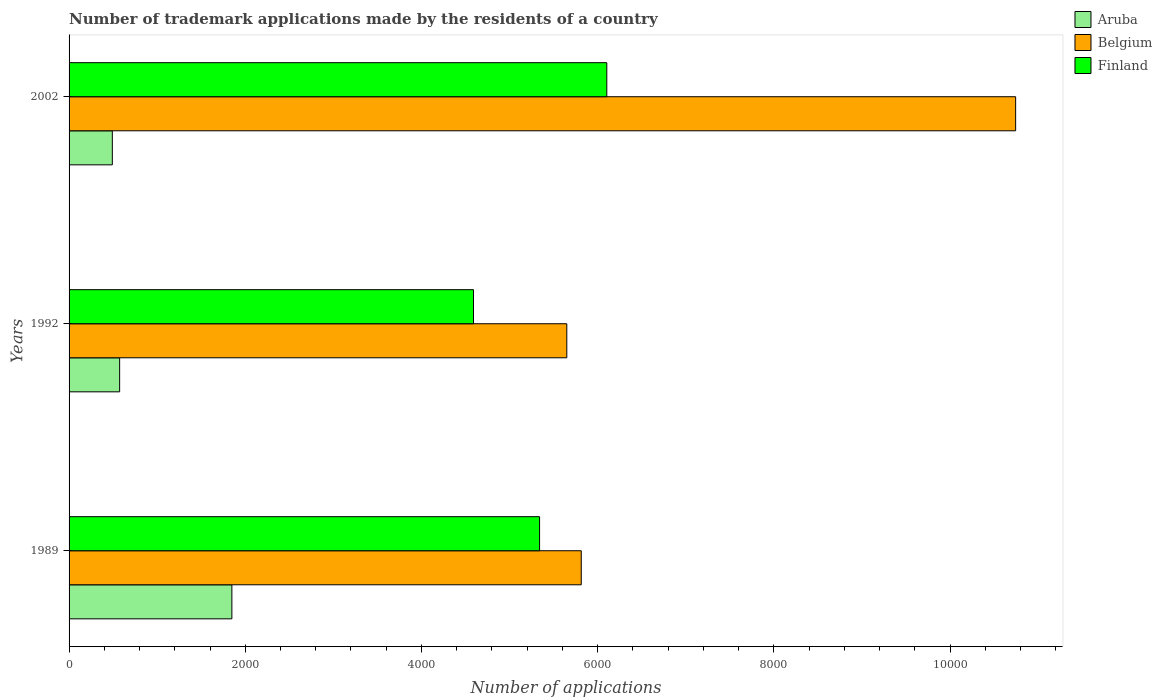How many groups of bars are there?
Ensure brevity in your answer.  3. Are the number of bars per tick equal to the number of legend labels?
Your answer should be very brief. Yes. Are the number of bars on each tick of the Y-axis equal?
Provide a succinct answer. Yes. How many bars are there on the 2nd tick from the bottom?
Make the answer very short. 3. What is the number of trademark applications made by the residents in Aruba in 2002?
Provide a short and direct response. 491. Across all years, what is the maximum number of trademark applications made by the residents in Aruba?
Make the answer very short. 1848. Across all years, what is the minimum number of trademark applications made by the residents in Belgium?
Your response must be concise. 5650. What is the total number of trademark applications made by the residents in Finland in the graph?
Give a very brief answer. 1.60e+04. What is the difference between the number of trademark applications made by the residents in Aruba in 1989 and that in 1992?
Your answer should be very brief. 1274. What is the difference between the number of trademark applications made by the residents in Belgium in 1989 and the number of trademark applications made by the residents in Aruba in 2002?
Offer a very short reply. 5323. What is the average number of trademark applications made by the residents in Belgium per year?
Keep it short and to the point. 7403. In the year 1992, what is the difference between the number of trademark applications made by the residents in Aruba and number of trademark applications made by the residents in Belgium?
Your answer should be very brief. -5076. What is the ratio of the number of trademark applications made by the residents in Belgium in 1989 to that in 2002?
Ensure brevity in your answer.  0.54. Is the number of trademark applications made by the residents in Belgium in 1989 less than that in 1992?
Make the answer very short. No. What is the difference between the highest and the second highest number of trademark applications made by the residents in Belgium?
Your answer should be compact. 4931. What is the difference between the highest and the lowest number of trademark applications made by the residents in Belgium?
Provide a succinct answer. 5095. Is the sum of the number of trademark applications made by the residents in Belgium in 1992 and 2002 greater than the maximum number of trademark applications made by the residents in Aruba across all years?
Provide a short and direct response. Yes. What does the 1st bar from the top in 2002 represents?
Provide a succinct answer. Finland. What does the 1st bar from the bottom in 1992 represents?
Offer a terse response. Aruba. Is it the case that in every year, the sum of the number of trademark applications made by the residents in Finland and number of trademark applications made by the residents in Aruba is greater than the number of trademark applications made by the residents in Belgium?
Offer a terse response. No. How many bars are there?
Your answer should be very brief. 9. How many years are there in the graph?
Ensure brevity in your answer.  3. Are the values on the major ticks of X-axis written in scientific E-notation?
Offer a terse response. No. Does the graph contain grids?
Provide a succinct answer. No. How many legend labels are there?
Give a very brief answer. 3. What is the title of the graph?
Your answer should be compact. Number of trademark applications made by the residents of a country. What is the label or title of the X-axis?
Keep it short and to the point. Number of applications. What is the label or title of the Y-axis?
Offer a very short reply. Years. What is the Number of applications in Aruba in 1989?
Your response must be concise. 1848. What is the Number of applications in Belgium in 1989?
Keep it short and to the point. 5814. What is the Number of applications of Finland in 1989?
Your answer should be very brief. 5341. What is the Number of applications in Aruba in 1992?
Give a very brief answer. 574. What is the Number of applications in Belgium in 1992?
Your answer should be compact. 5650. What is the Number of applications in Finland in 1992?
Make the answer very short. 4591. What is the Number of applications in Aruba in 2002?
Offer a very short reply. 491. What is the Number of applications of Belgium in 2002?
Offer a very short reply. 1.07e+04. What is the Number of applications of Finland in 2002?
Offer a very short reply. 6104. Across all years, what is the maximum Number of applications of Aruba?
Offer a terse response. 1848. Across all years, what is the maximum Number of applications in Belgium?
Make the answer very short. 1.07e+04. Across all years, what is the maximum Number of applications of Finland?
Keep it short and to the point. 6104. Across all years, what is the minimum Number of applications of Aruba?
Keep it short and to the point. 491. Across all years, what is the minimum Number of applications in Belgium?
Provide a short and direct response. 5650. Across all years, what is the minimum Number of applications of Finland?
Your answer should be very brief. 4591. What is the total Number of applications in Aruba in the graph?
Offer a terse response. 2913. What is the total Number of applications in Belgium in the graph?
Keep it short and to the point. 2.22e+04. What is the total Number of applications of Finland in the graph?
Your response must be concise. 1.60e+04. What is the difference between the Number of applications of Aruba in 1989 and that in 1992?
Make the answer very short. 1274. What is the difference between the Number of applications in Belgium in 1989 and that in 1992?
Give a very brief answer. 164. What is the difference between the Number of applications of Finland in 1989 and that in 1992?
Ensure brevity in your answer.  750. What is the difference between the Number of applications of Aruba in 1989 and that in 2002?
Offer a very short reply. 1357. What is the difference between the Number of applications of Belgium in 1989 and that in 2002?
Give a very brief answer. -4931. What is the difference between the Number of applications of Finland in 1989 and that in 2002?
Give a very brief answer. -763. What is the difference between the Number of applications of Aruba in 1992 and that in 2002?
Keep it short and to the point. 83. What is the difference between the Number of applications of Belgium in 1992 and that in 2002?
Keep it short and to the point. -5095. What is the difference between the Number of applications in Finland in 1992 and that in 2002?
Offer a very short reply. -1513. What is the difference between the Number of applications in Aruba in 1989 and the Number of applications in Belgium in 1992?
Offer a very short reply. -3802. What is the difference between the Number of applications of Aruba in 1989 and the Number of applications of Finland in 1992?
Ensure brevity in your answer.  -2743. What is the difference between the Number of applications in Belgium in 1989 and the Number of applications in Finland in 1992?
Give a very brief answer. 1223. What is the difference between the Number of applications in Aruba in 1989 and the Number of applications in Belgium in 2002?
Your answer should be very brief. -8897. What is the difference between the Number of applications in Aruba in 1989 and the Number of applications in Finland in 2002?
Ensure brevity in your answer.  -4256. What is the difference between the Number of applications of Belgium in 1989 and the Number of applications of Finland in 2002?
Your answer should be very brief. -290. What is the difference between the Number of applications in Aruba in 1992 and the Number of applications in Belgium in 2002?
Give a very brief answer. -1.02e+04. What is the difference between the Number of applications in Aruba in 1992 and the Number of applications in Finland in 2002?
Make the answer very short. -5530. What is the difference between the Number of applications of Belgium in 1992 and the Number of applications of Finland in 2002?
Provide a succinct answer. -454. What is the average Number of applications in Aruba per year?
Your answer should be very brief. 971. What is the average Number of applications of Belgium per year?
Your answer should be compact. 7403. What is the average Number of applications of Finland per year?
Make the answer very short. 5345.33. In the year 1989, what is the difference between the Number of applications in Aruba and Number of applications in Belgium?
Offer a terse response. -3966. In the year 1989, what is the difference between the Number of applications of Aruba and Number of applications of Finland?
Offer a very short reply. -3493. In the year 1989, what is the difference between the Number of applications of Belgium and Number of applications of Finland?
Provide a short and direct response. 473. In the year 1992, what is the difference between the Number of applications in Aruba and Number of applications in Belgium?
Your answer should be compact. -5076. In the year 1992, what is the difference between the Number of applications in Aruba and Number of applications in Finland?
Your answer should be compact. -4017. In the year 1992, what is the difference between the Number of applications of Belgium and Number of applications of Finland?
Make the answer very short. 1059. In the year 2002, what is the difference between the Number of applications in Aruba and Number of applications in Belgium?
Give a very brief answer. -1.03e+04. In the year 2002, what is the difference between the Number of applications in Aruba and Number of applications in Finland?
Offer a terse response. -5613. In the year 2002, what is the difference between the Number of applications of Belgium and Number of applications of Finland?
Your answer should be compact. 4641. What is the ratio of the Number of applications of Aruba in 1989 to that in 1992?
Keep it short and to the point. 3.22. What is the ratio of the Number of applications in Finland in 1989 to that in 1992?
Keep it short and to the point. 1.16. What is the ratio of the Number of applications of Aruba in 1989 to that in 2002?
Your response must be concise. 3.76. What is the ratio of the Number of applications of Belgium in 1989 to that in 2002?
Your response must be concise. 0.54. What is the ratio of the Number of applications of Finland in 1989 to that in 2002?
Your answer should be compact. 0.88. What is the ratio of the Number of applications in Aruba in 1992 to that in 2002?
Provide a succinct answer. 1.17. What is the ratio of the Number of applications in Belgium in 1992 to that in 2002?
Provide a succinct answer. 0.53. What is the ratio of the Number of applications of Finland in 1992 to that in 2002?
Ensure brevity in your answer.  0.75. What is the difference between the highest and the second highest Number of applications in Aruba?
Provide a short and direct response. 1274. What is the difference between the highest and the second highest Number of applications of Belgium?
Ensure brevity in your answer.  4931. What is the difference between the highest and the second highest Number of applications of Finland?
Your answer should be very brief. 763. What is the difference between the highest and the lowest Number of applications of Aruba?
Offer a very short reply. 1357. What is the difference between the highest and the lowest Number of applications in Belgium?
Your answer should be very brief. 5095. What is the difference between the highest and the lowest Number of applications in Finland?
Keep it short and to the point. 1513. 